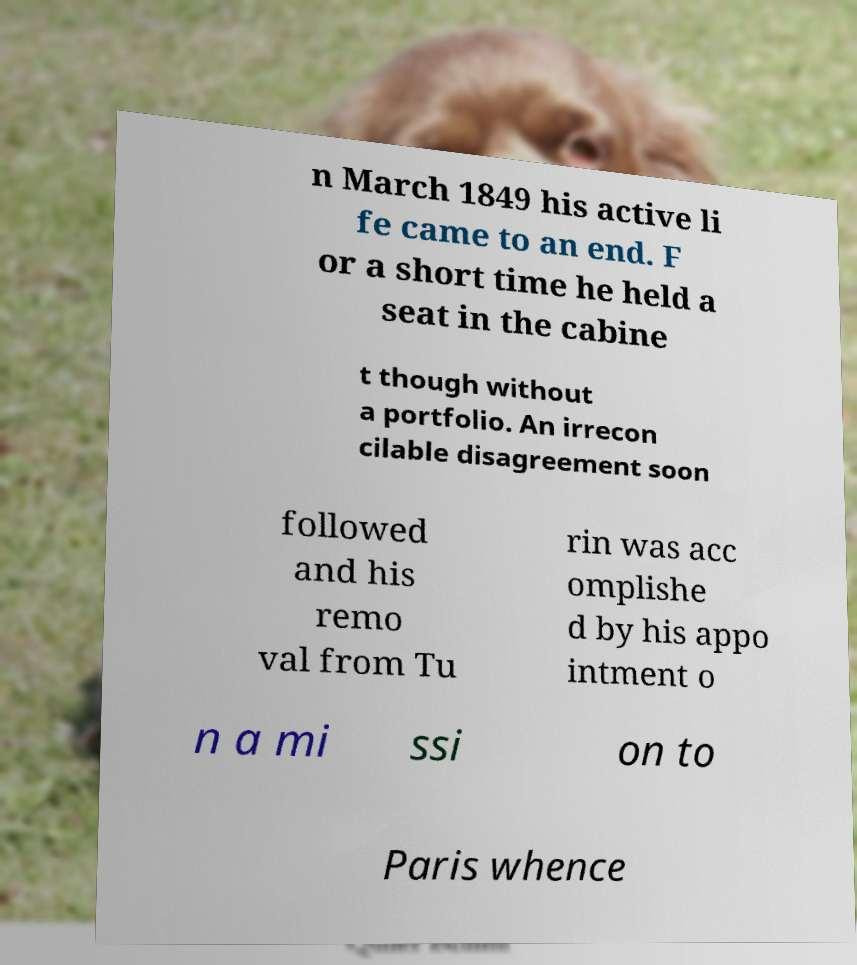Can you accurately transcribe the text from the provided image for me? n March 1849 his active li fe came to an end. F or a short time he held a seat in the cabine t though without a portfolio. An irrecon cilable disagreement soon followed and his remo val from Tu rin was acc omplishe d by his appo intment o n a mi ssi on to Paris whence 